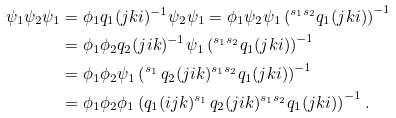Convert formula to latex. <formula><loc_0><loc_0><loc_500><loc_500>\psi _ { 1 } \psi _ { 2 } \psi _ { 1 } & = \phi _ { 1 } q _ { 1 } ( j k i ) ^ { - 1 } \psi _ { 2 } \psi _ { 1 } = \phi _ { 1 } \psi _ { 2 } \psi _ { 1 } \left ( { ^ { s _ { 1 } s _ { 2 } } } q _ { 1 } ( j k i ) \right ) ^ { - 1 } \\ & = \phi _ { 1 } \phi _ { 2 } q _ { 2 } ( j i k ) ^ { - 1 } \psi _ { 1 } \left ( { ^ { s _ { 1 } s _ { 2 } } } q _ { 1 } ( j k i ) \right ) ^ { - 1 } \\ & = \phi _ { 1 } \phi _ { 2 } \psi _ { 1 } \left ( { ^ { s _ { 1 } \, } } q _ { 2 } ( j i k ) { ^ { s _ { 1 } s _ { 2 } } } q _ { 1 } ( j k i ) \right ) ^ { - 1 } \\ & = \phi _ { 1 } \phi _ { 2 } \phi _ { 1 } \left ( q _ { 1 } ( i j k ) { ^ { s _ { 1 } \, } } q _ { 2 } ( j i k ) { ^ { s _ { 1 } s _ { 2 } } } q _ { 1 } ( j k i ) \right ) ^ { - 1 } .</formula> 